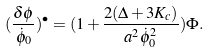<formula> <loc_0><loc_0><loc_500><loc_500>( \frac { \delta \phi } { \dot { \phi } _ { 0 } } ) ^ { \bullet } = ( 1 + \frac { 2 ( \Delta + 3 K _ { c } ) } { a ^ { 2 } \dot { \phi } _ { 0 } ^ { 2 } } ) \Phi .</formula> 